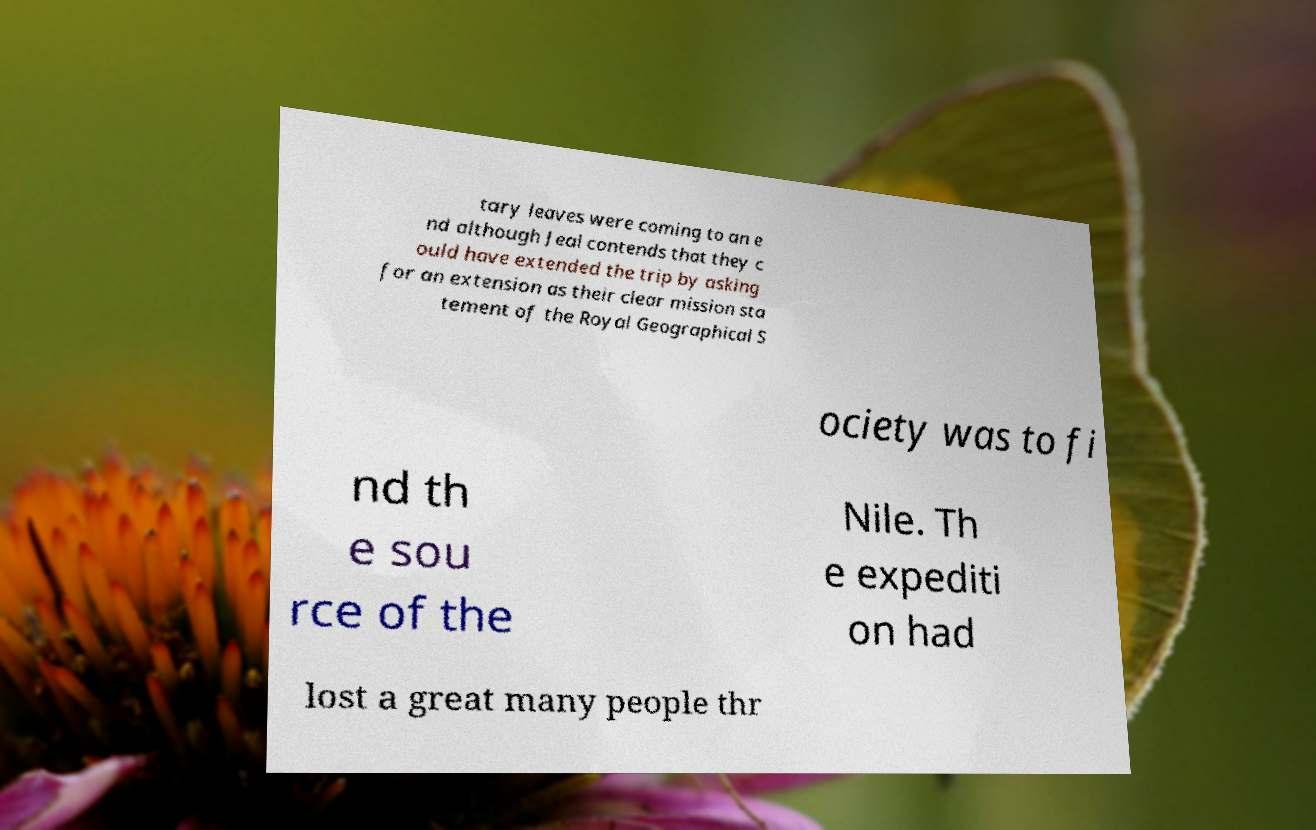There's text embedded in this image that I need extracted. Can you transcribe it verbatim? tary leaves were coming to an e nd although Jeal contends that they c ould have extended the trip by asking for an extension as their clear mission sta tement of the Royal Geographical S ociety was to fi nd th e sou rce of the Nile. Th e expediti on had lost a great many people thr 